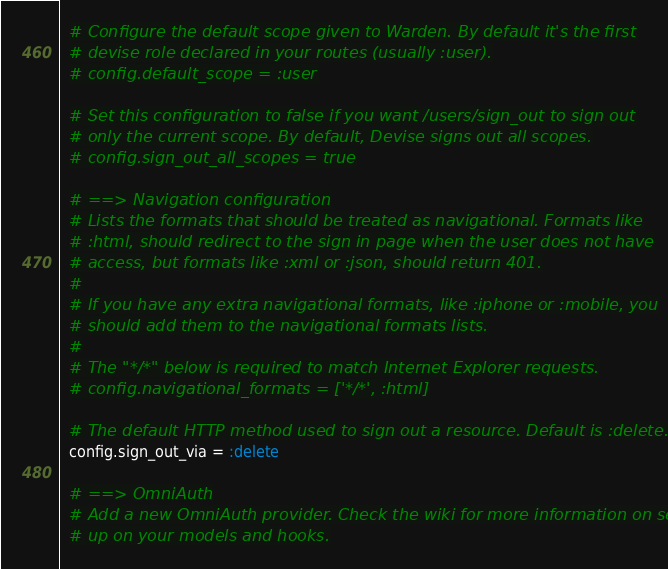<code> <loc_0><loc_0><loc_500><loc_500><_Ruby_>
  # Configure the default scope given to Warden. By default it's the first
  # devise role declared in your routes (usually :user).
  # config.default_scope = :user

  # Set this configuration to false if you want /users/sign_out to sign out
  # only the current scope. By default, Devise signs out all scopes.
  # config.sign_out_all_scopes = true

  # ==> Navigation configuration
  # Lists the formats that should be treated as navigational. Formats like
  # :html, should redirect to the sign in page when the user does not have
  # access, but formats like :xml or :json, should return 401.
  #
  # If you have any extra navigational formats, like :iphone or :mobile, you
  # should add them to the navigational formats lists.
  #
  # The "*/*" below is required to match Internet Explorer requests.
  # config.navigational_formats = ['*/*', :html]

  # The default HTTP method used to sign out a resource. Default is :delete.
  config.sign_out_via = :delete

  # ==> OmniAuth
  # Add a new OmniAuth provider. Check the wiki for more information on setting
  # up on your models and hooks.</code> 